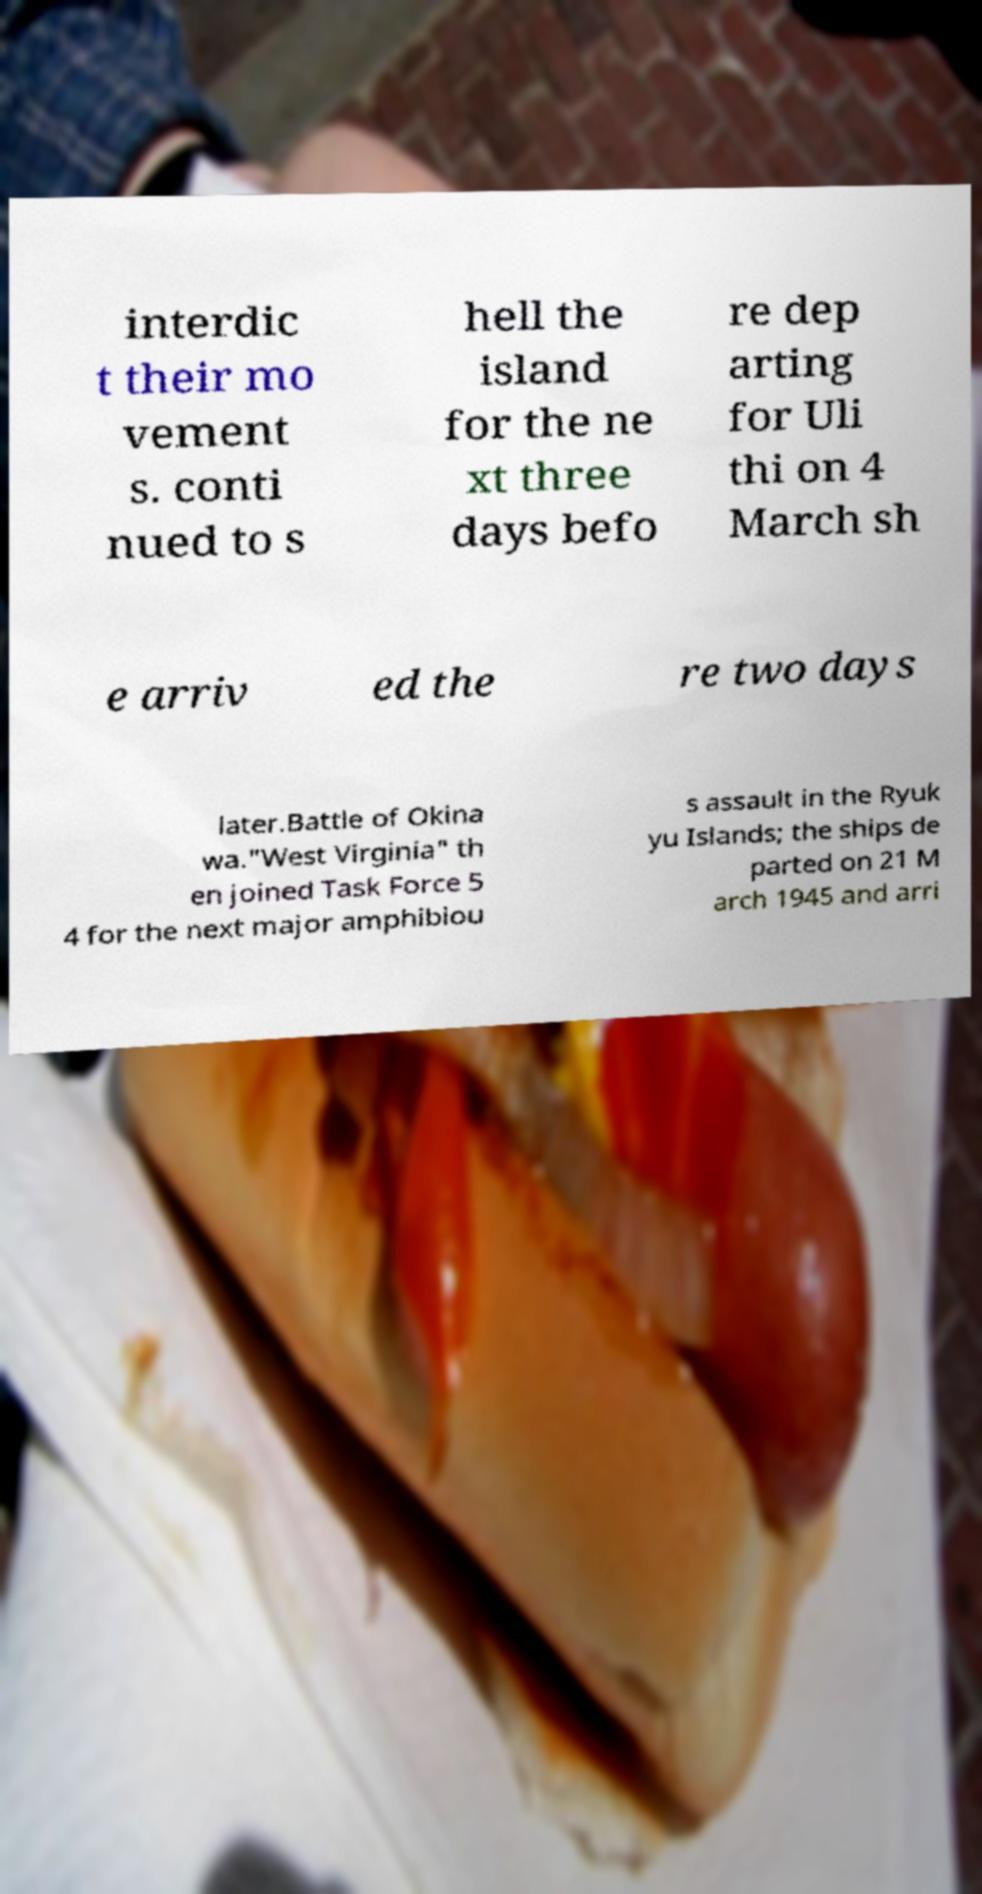Please identify and transcribe the text found in this image. interdic t their mo vement s. conti nued to s hell the island for the ne xt three days befo re dep arting for Uli thi on 4 March sh e arriv ed the re two days later.Battle of Okina wa."West Virginia" th en joined Task Force 5 4 for the next major amphibiou s assault in the Ryuk yu Islands; the ships de parted on 21 M arch 1945 and arri 